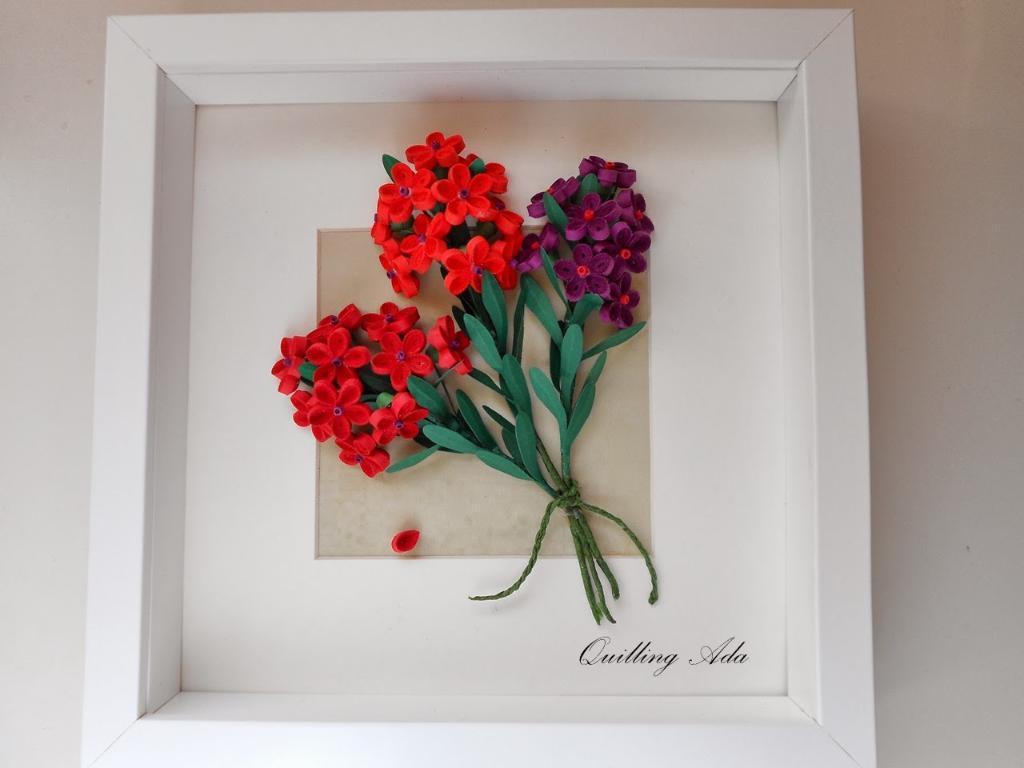Can you describe this image briefly? In this image we can see artificial bouquet in the box. There is some text on the box at the bottom of the image. There is a white background in the image. 